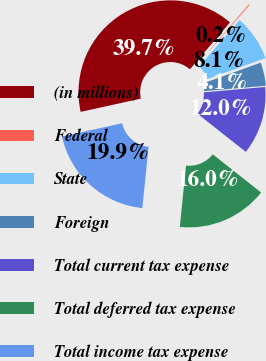Convert chart to OTSL. <chart><loc_0><loc_0><loc_500><loc_500><pie_chart><fcel>(in millions)<fcel>Federal<fcel>State<fcel>Foreign<fcel>Total current tax expense<fcel>Total deferred tax expense<fcel>Total income tax expense<nl><fcel>39.72%<fcel>0.16%<fcel>8.07%<fcel>4.11%<fcel>12.03%<fcel>15.98%<fcel>19.94%<nl></chart> 